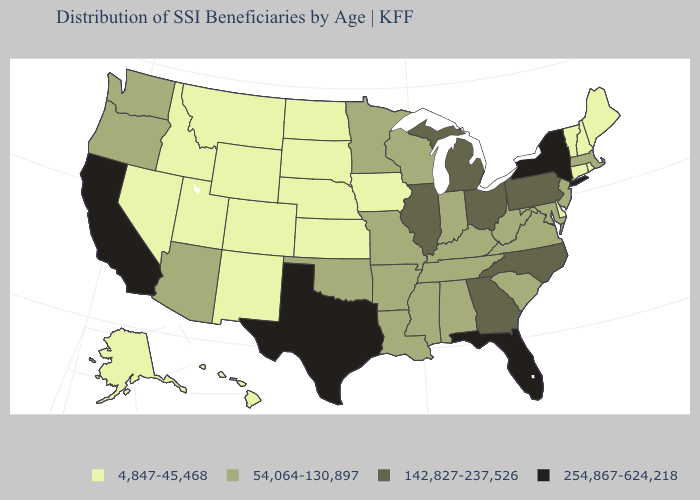Among the states that border Wyoming , which have the highest value?
Keep it brief. Colorado, Idaho, Montana, Nebraska, South Dakota, Utah. Name the states that have a value in the range 142,827-237,526?
Short answer required. Georgia, Illinois, Michigan, North Carolina, Ohio, Pennsylvania. Among the states that border New Jersey , which have the highest value?
Keep it brief. New York. What is the value of New York?
Be succinct. 254,867-624,218. Does the map have missing data?
Quick response, please. No. What is the value of Texas?
Keep it brief. 254,867-624,218. Name the states that have a value in the range 142,827-237,526?
Keep it brief. Georgia, Illinois, Michigan, North Carolina, Ohio, Pennsylvania. Among the states that border New Hampshire , does Massachusetts have the lowest value?
Keep it brief. No. Does Georgia have the highest value in the USA?
Give a very brief answer. No. What is the value of Oklahoma?
Be succinct. 54,064-130,897. What is the value of Iowa?
Answer briefly. 4,847-45,468. Name the states that have a value in the range 254,867-624,218?
Quick response, please. California, Florida, New York, Texas. What is the lowest value in the Northeast?
Quick response, please. 4,847-45,468. What is the value of Illinois?
Give a very brief answer. 142,827-237,526. Which states have the lowest value in the USA?
Give a very brief answer. Alaska, Colorado, Connecticut, Delaware, Hawaii, Idaho, Iowa, Kansas, Maine, Montana, Nebraska, Nevada, New Hampshire, New Mexico, North Dakota, Rhode Island, South Dakota, Utah, Vermont, Wyoming. 